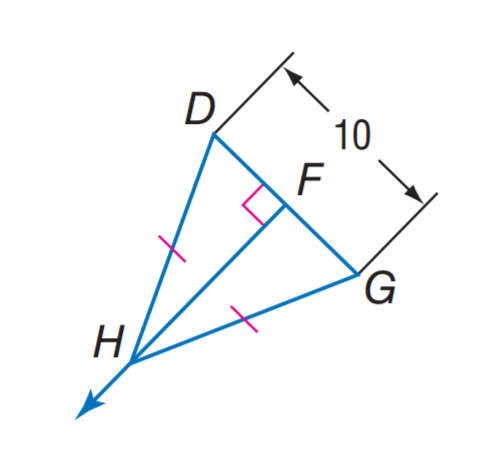Question: Find D F.
Choices:
A. 5
B. 10
C. 15
D. 20
Answer with the letter. Answer: A 